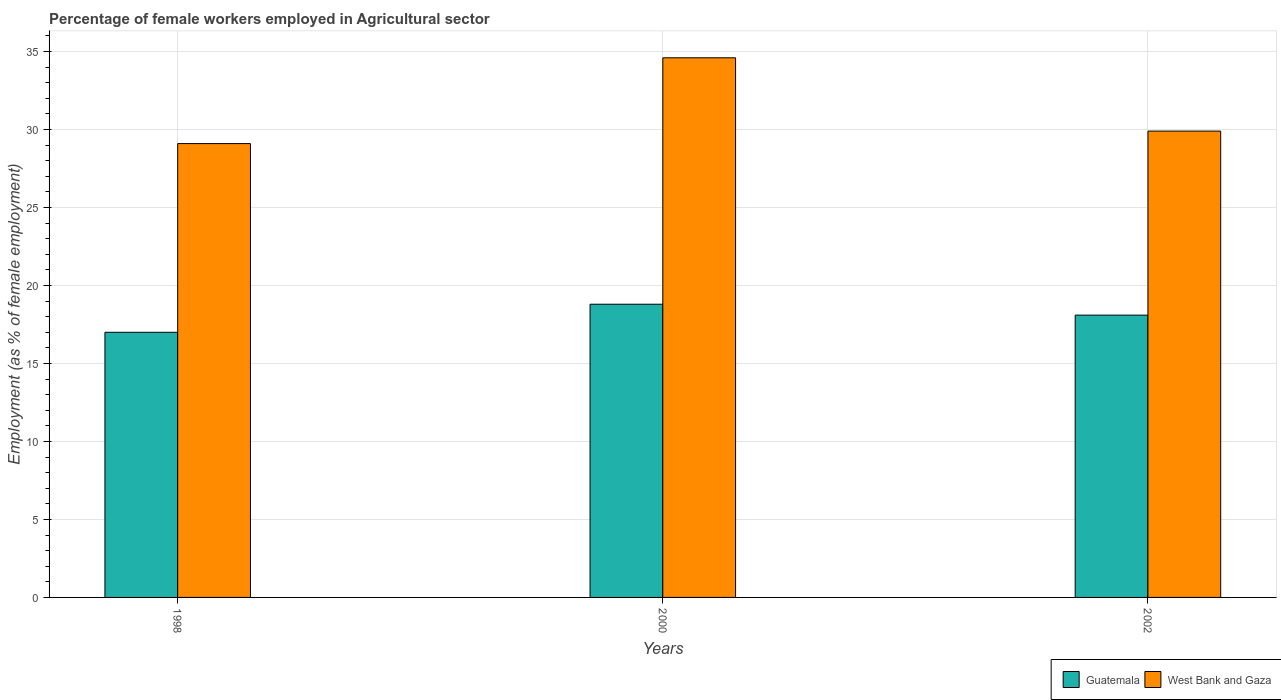How many different coloured bars are there?
Offer a terse response. 2. Are the number of bars per tick equal to the number of legend labels?
Provide a short and direct response. Yes. Are the number of bars on each tick of the X-axis equal?
Your response must be concise. Yes. How many bars are there on the 3rd tick from the right?
Offer a terse response. 2. What is the percentage of females employed in Agricultural sector in Guatemala in 2002?
Offer a terse response. 18.1. Across all years, what is the maximum percentage of females employed in Agricultural sector in Guatemala?
Your answer should be very brief. 18.8. In which year was the percentage of females employed in Agricultural sector in West Bank and Gaza maximum?
Make the answer very short. 2000. In which year was the percentage of females employed in Agricultural sector in West Bank and Gaza minimum?
Provide a short and direct response. 1998. What is the total percentage of females employed in Agricultural sector in West Bank and Gaza in the graph?
Provide a succinct answer. 93.6. What is the difference between the percentage of females employed in Agricultural sector in West Bank and Gaza in 1998 and that in 2000?
Provide a short and direct response. -5.5. What is the difference between the percentage of females employed in Agricultural sector in West Bank and Gaza in 2000 and the percentage of females employed in Agricultural sector in Guatemala in 2002?
Provide a succinct answer. 16.5. What is the average percentage of females employed in Agricultural sector in Guatemala per year?
Your response must be concise. 17.97. In the year 2002, what is the difference between the percentage of females employed in Agricultural sector in Guatemala and percentage of females employed in Agricultural sector in West Bank and Gaza?
Your response must be concise. -11.8. What is the ratio of the percentage of females employed in Agricultural sector in West Bank and Gaza in 2000 to that in 2002?
Your answer should be compact. 1.16. Is the percentage of females employed in Agricultural sector in West Bank and Gaza in 1998 less than that in 2000?
Your response must be concise. Yes. What is the difference between the highest and the second highest percentage of females employed in Agricultural sector in Guatemala?
Your answer should be very brief. 0.7. What is the difference between the highest and the lowest percentage of females employed in Agricultural sector in Guatemala?
Ensure brevity in your answer.  1.8. In how many years, is the percentage of females employed in Agricultural sector in Guatemala greater than the average percentage of females employed in Agricultural sector in Guatemala taken over all years?
Your answer should be very brief. 2. Is the sum of the percentage of females employed in Agricultural sector in Guatemala in 1998 and 2002 greater than the maximum percentage of females employed in Agricultural sector in West Bank and Gaza across all years?
Ensure brevity in your answer.  Yes. What does the 2nd bar from the left in 1998 represents?
Your answer should be very brief. West Bank and Gaza. What does the 2nd bar from the right in 1998 represents?
Your answer should be very brief. Guatemala. What is the difference between two consecutive major ticks on the Y-axis?
Your response must be concise. 5. Are the values on the major ticks of Y-axis written in scientific E-notation?
Ensure brevity in your answer.  No. Does the graph contain any zero values?
Offer a very short reply. No. Where does the legend appear in the graph?
Provide a succinct answer. Bottom right. How many legend labels are there?
Offer a terse response. 2. What is the title of the graph?
Make the answer very short. Percentage of female workers employed in Agricultural sector. What is the label or title of the X-axis?
Provide a succinct answer. Years. What is the label or title of the Y-axis?
Your answer should be very brief. Employment (as % of female employment). What is the Employment (as % of female employment) in Guatemala in 1998?
Your answer should be compact. 17. What is the Employment (as % of female employment) in West Bank and Gaza in 1998?
Your answer should be very brief. 29.1. What is the Employment (as % of female employment) of Guatemala in 2000?
Offer a terse response. 18.8. What is the Employment (as % of female employment) of West Bank and Gaza in 2000?
Provide a succinct answer. 34.6. What is the Employment (as % of female employment) in Guatemala in 2002?
Ensure brevity in your answer.  18.1. What is the Employment (as % of female employment) of West Bank and Gaza in 2002?
Your response must be concise. 29.9. Across all years, what is the maximum Employment (as % of female employment) of Guatemala?
Your answer should be compact. 18.8. Across all years, what is the maximum Employment (as % of female employment) in West Bank and Gaza?
Offer a terse response. 34.6. Across all years, what is the minimum Employment (as % of female employment) in West Bank and Gaza?
Your response must be concise. 29.1. What is the total Employment (as % of female employment) in Guatemala in the graph?
Provide a succinct answer. 53.9. What is the total Employment (as % of female employment) in West Bank and Gaza in the graph?
Your answer should be very brief. 93.6. What is the difference between the Employment (as % of female employment) in Guatemala in 1998 and that in 2000?
Ensure brevity in your answer.  -1.8. What is the difference between the Employment (as % of female employment) of Guatemala in 1998 and that in 2002?
Give a very brief answer. -1.1. What is the difference between the Employment (as % of female employment) of West Bank and Gaza in 1998 and that in 2002?
Ensure brevity in your answer.  -0.8. What is the difference between the Employment (as % of female employment) in Guatemala in 2000 and that in 2002?
Give a very brief answer. 0.7. What is the difference between the Employment (as % of female employment) of Guatemala in 1998 and the Employment (as % of female employment) of West Bank and Gaza in 2000?
Give a very brief answer. -17.6. What is the difference between the Employment (as % of female employment) in Guatemala in 1998 and the Employment (as % of female employment) in West Bank and Gaza in 2002?
Ensure brevity in your answer.  -12.9. What is the difference between the Employment (as % of female employment) of Guatemala in 2000 and the Employment (as % of female employment) of West Bank and Gaza in 2002?
Offer a terse response. -11.1. What is the average Employment (as % of female employment) of Guatemala per year?
Give a very brief answer. 17.97. What is the average Employment (as % of female employment) in West Bank and Gaza per year?
Keep it short and to the point. 31.2. In the year 2000, what is the difference between the Employment (as % of female employment) of Guatemala and Employment (as % of female employment) of West Bank and Gaza?
Your answer should be very brief. -15.8. What is the ratio of the Employment (as % of female employment) in Guatemala in 1998 to that in 2000?
Provide a short and direct response. 0.9. What is the ratio of the Employment (as % of female employment) in West Bank and Gaza in 1998 to that in 2000?
Offer a very short reply. 0.84. What is the ratio of the Employment (as % of female employment) in Guatemala in 1998 to that in 2002?
Give a very brief answer. 0.94. What is the ratio of the Employment (as % of female employment) in West Bank and Gaza in 1998 to that in 2002?
Give a very brief answer. 0.97. What is the ratio of the Employment (as % of female employment) of Guatemala in 2000 to that in 2002?
Your answer should be compact. 1.04. What is the ratio of the Employment (as % of female employment) of West Bank and Gaza in 2000 to that in 2002?
Ensure brevity in your answer.  1.16. What is the difference between the highest and the second highest Employment (as % of female employment) of Guatemala?
Ensure brevity in your answer.  0.7. 